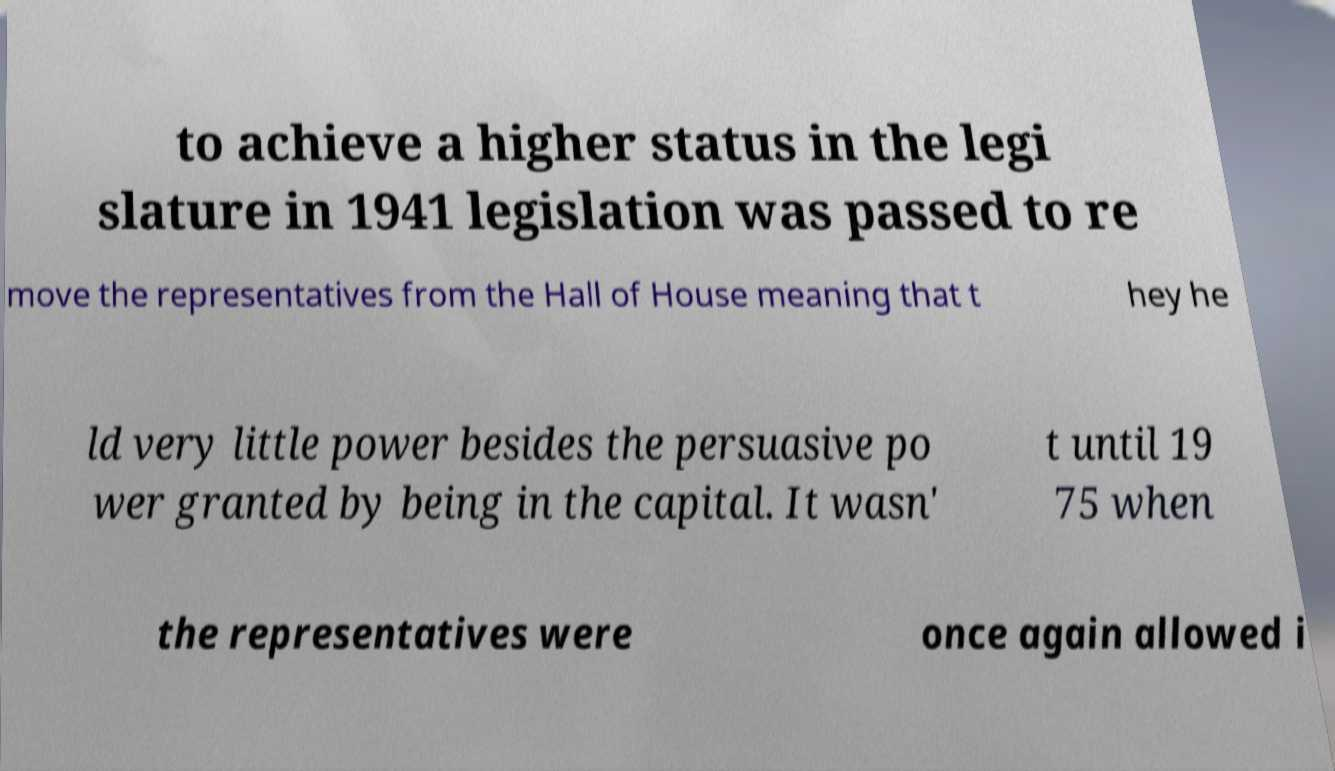What messages or text are displayed in this image? I need them in a readable, typed format. to achieve a higher status in the legi slature in 1941 legislation was passed to re move the representatives from the Hall of House meaning that t hey he ld very little power besides the persuasive po wer granted by being in the capital. It wasn' t until 19 75 when the representatives were once again allowed i 